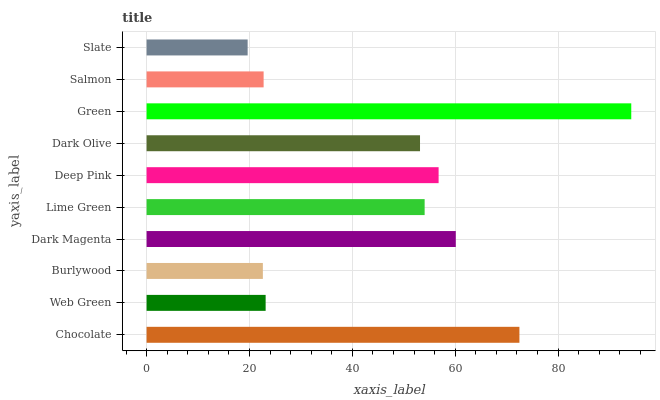Is Slate the minimum?
Answer yes or no. Yes. Is Green the maximum?
Answer yes or no. Yes. Is Web Green the minimum?
Answer yes or no. No. Is Web Green the maximum?
Answer yes or no. No. Is Chocolate greater than Web Green?
Answer yes or no. Yes. Is Web Green less than Chocolate?
Answer yes or no. Yes. Is Web Green greater than Chocolate?
Answer yes or no. No. Is Chocolate less than Web Green?
Answer yes or no. No. Is Lime Green the high median?
Answer yes or no. Yes. Is Dark Olive the low median?
Answer yes or no. Yes. Is Deep Pink the high median?
Answer yes or no. No. Is Salmon the low median?
Answer yes or no. No. 